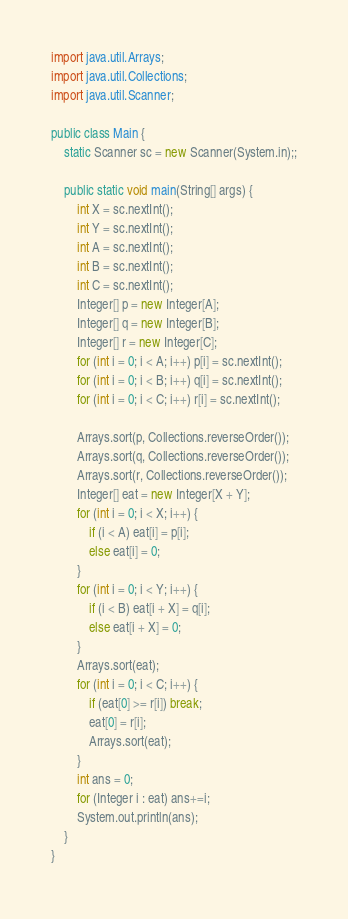Convert code to text. <code><loc_0><loc_0><loc_500><loc_500><_Java_>import java.util.Arrays;
import java.util.Collections;
import java.util.Scanner;

public class Main {
    static Scanner sc = new Scanner(System.in);;

    public static void main(String[] args) {
        int X = sc.nextInt();
        int Y = sc.nextInt();
        int A = sc.nextInt();
        int B = sc.nextInt();
        int C = sc.nextInt();
        Integer[] p = new Integer[A];
        Integer[] q = new Integer[B];
        Integer[] r = new Integer[C];
        for (int i = 0; i < A; i++) p[i] = sc.nextInt();
        for (int i = 0; i < B; i++) q[i] = sc.nextInt();
        for (int i = 0; i < C; i++) r[i] = sc.nextInt();

        Arrays.sort(p, Collections.reverseOrder());
        Arrays.sort(q, Collections.reverseOrder());
        Arrays.sort(r, Collections.reverseOrder());
        Integer[] eat = new Integer[X + Y];
        for (int i = 0; i < X; i++) {
            if (i < A) eat[i] = p[i];
            else eat[i] = 0;
        }
        for (int i = 0; i < Y; i++) {
            if (i < B) eat[i + X] = q[i];
            else eat[i + X] = 0;
        }
        Arrays.sort(eat);
        for (int i = 0; i < C; i++) {
            if (eat[0] >= r[i]) break;
            eat[0] = r[i];
            Arrays.sort(eat);
        }
        int ans = 0;
        for (Integer i : eat) ans+=i;
        System.out.println(ans);
    }
}
</code> 